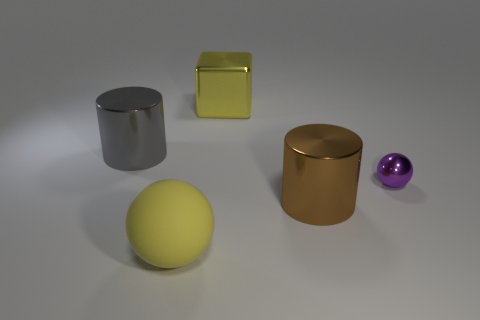Add 3 matte things. How many objects exist? 8 Subtract all blocks. How many objects are left? 4 Add 3 brown cylinders. How many brown cylinders exist? 4 Subtract 1 purple balls. How many objects are left? 4 Subtract all shiny objects. Subtract all small gray metal cylinders. How many objects are left? 1 Add 2 large yellow cubes. How many large yellow cubes are left? 3 